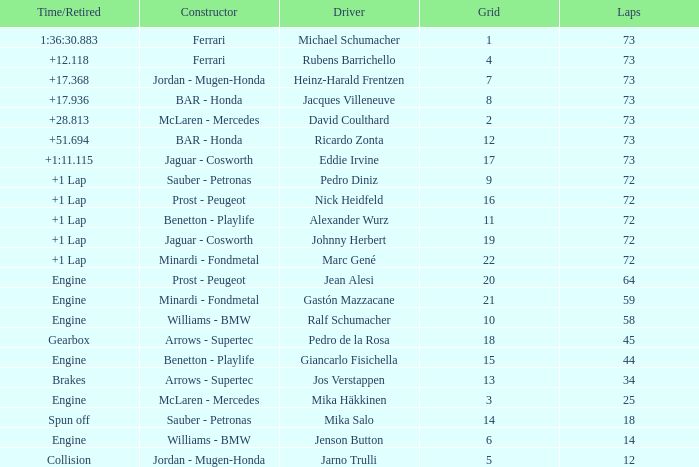How many laps did Giancarlo Fisichella do with a grid larger than 15? 0.0. 